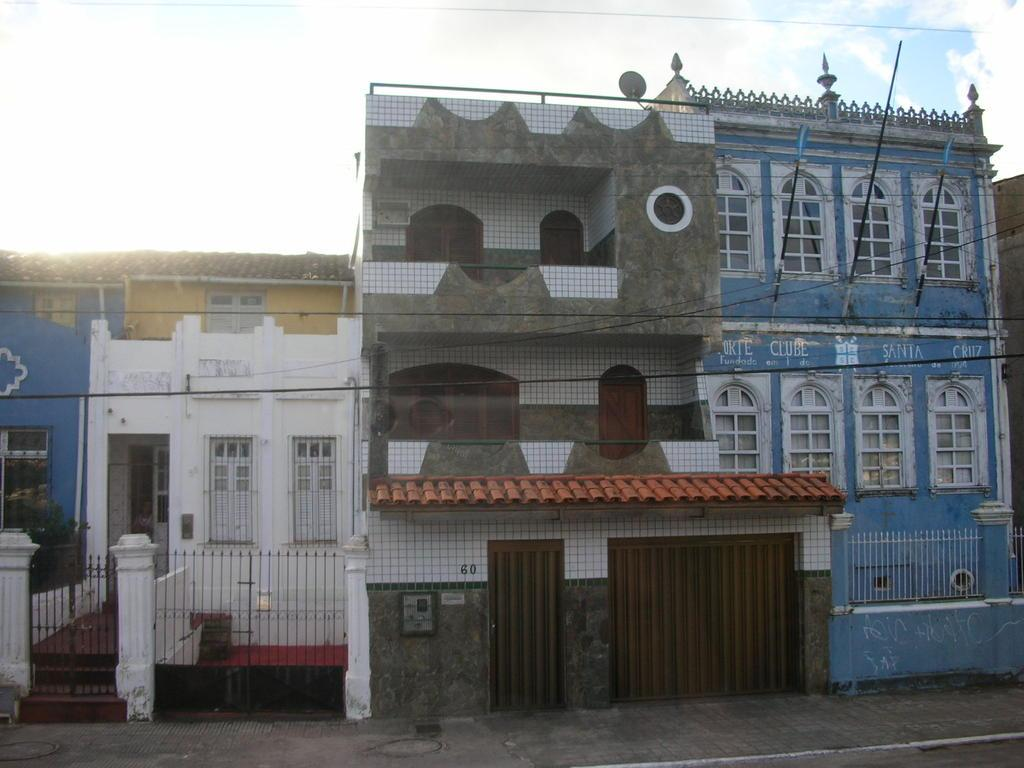What is in the foreground of the image? There is a pavement in the foreground of the image. What can be seen in the middle of the image? There are buildings in the middle of the image. What is visible at the top of the image? The sky is visible at the top of the image. Where is the uncle located in the image? There is no uncle present in the image. What type of street is shown in the image? The image does not depict a street; it features a pavement in the foreground and buildings in the middle. 